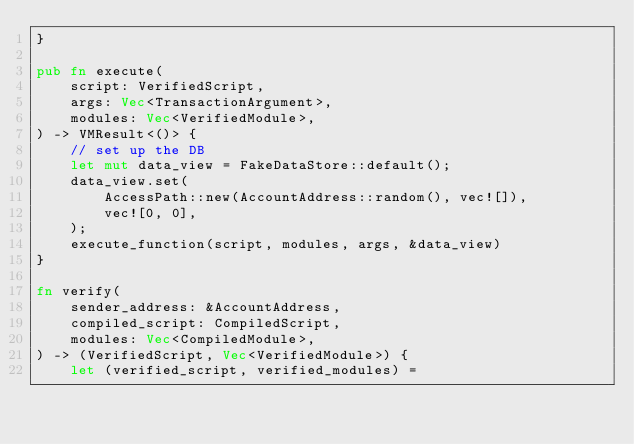Convert code to text. <code><loc_0><loc_0><loc_500><loc_500><_Rust_>}

pub fn execute(
    script: VerifiedScript,
    args: Vec<TransactionArgument>,
    modules: Vec<VerifiedModule>,
) -> VMResult<()> {
    // set up the DB
    let mut data_view = FakeDataStore::default();
    data_view.set(
        AccessPath::new(AccountAddress::random(), vec![]),
        vec![0, 0],
    );
    execute_function(script, modules, args, &data_view)
}

fn verify(
    sender_address: &AccountAddress,
    compiled_script: CompiledScript,
    modules: Vec<CompiledModule>,
) -> (VerifiedScript, Vec<VerifiedModule>) {
    let (verified_script, verified_modules) =</code> 